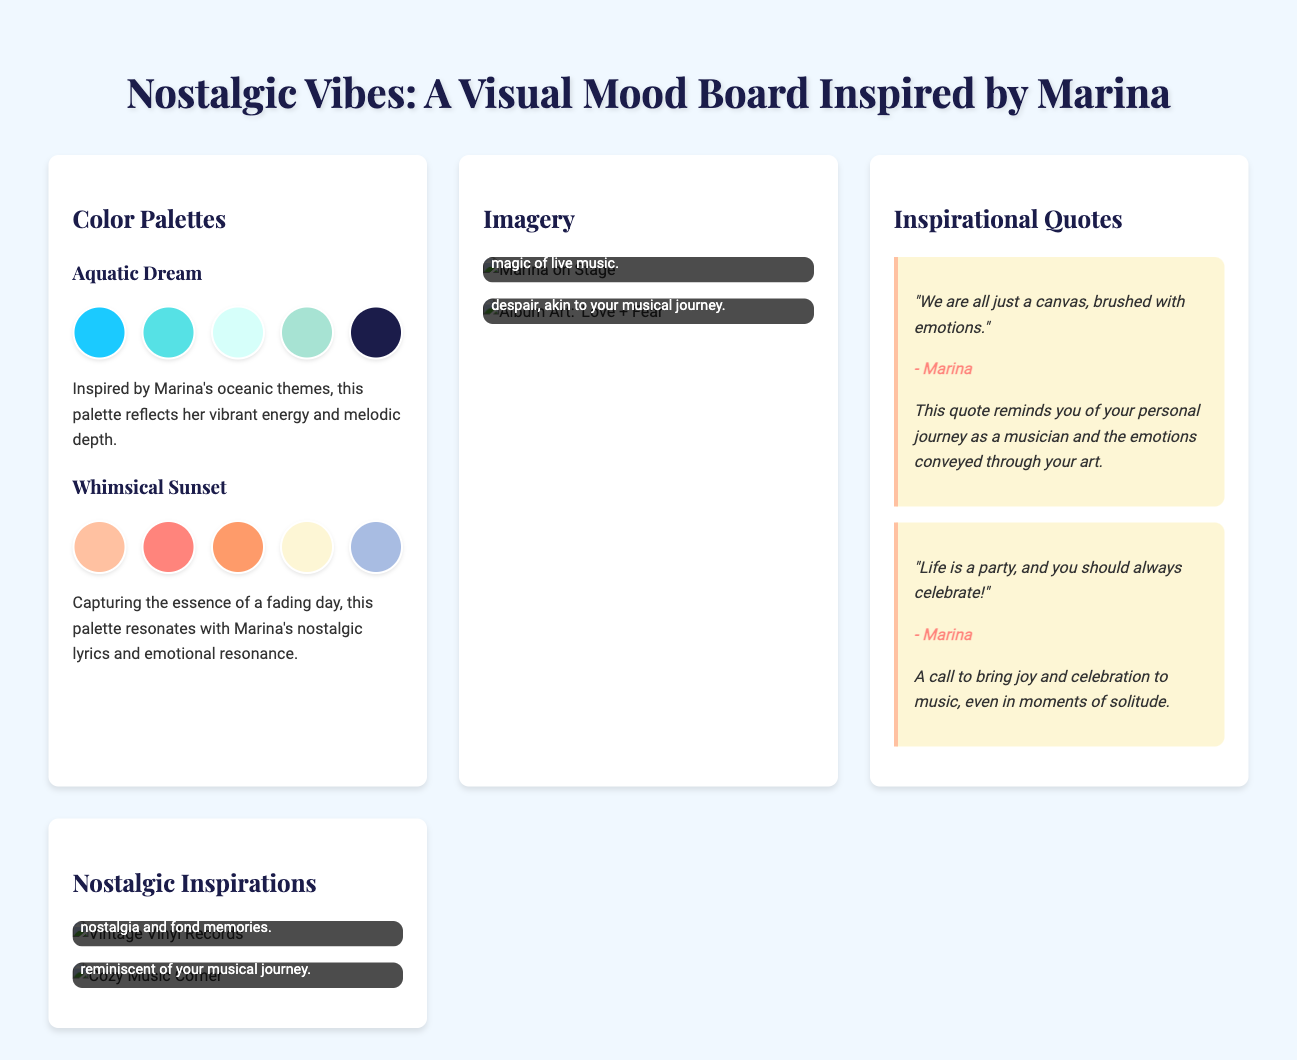what is the title of the mood board? The title of the mood board is presented at the beginning of the document.
Answer: Nostalgic Vibes: A Visual Mood Board Inspired by Marina how many color palettes are featured? The document lists different sections, including color palettes, and specifies the number in the Color Palettes section.
Answer: 2 what is the color of the first swatch in the "Whimsical Sunset" palette? The first swatch's color in the "Whimsical Sunset" palette is indicated by its background color description.
Answer: #FFC1A1 which artist is the inspiration for this mood board? The document repeatedly references the artist associated with the mood board, confirming their identity.
Answer: Marina what is the main emotion captured by the "Aquatic Dream" color palette? The description of the "Aquatic Dream" palette mentions its reflective qualities and energetic themes.
Answer: Vibrant energy and melodic depth what is the message of the quote “Life is a party, and you should always celebrate!”? The document explains the significance of this quote, relating it to a joyful approach to music.
Answer: Celebration what kind of imagery is included in the mood board? The document provides descriptions of the types of images presented in the Imagery section.
Answer: Performance and album art how many quotes from Marina are included? The number of quotes provided in the Inspirational Quotes section is specified in the document.
Answer: 2 what does the nostalgic inspiration image of “Vintage Vinyl Records” evoke? The caption under the image describes the feelings associated with vintage vinyl records.
Answer: Nostalgia and fond memories 